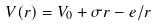<formula> <loc_0><loc_0><loc_500><loc_500>V ( r ) = V _ { 0 } + \sigma r - e / r</formula> 